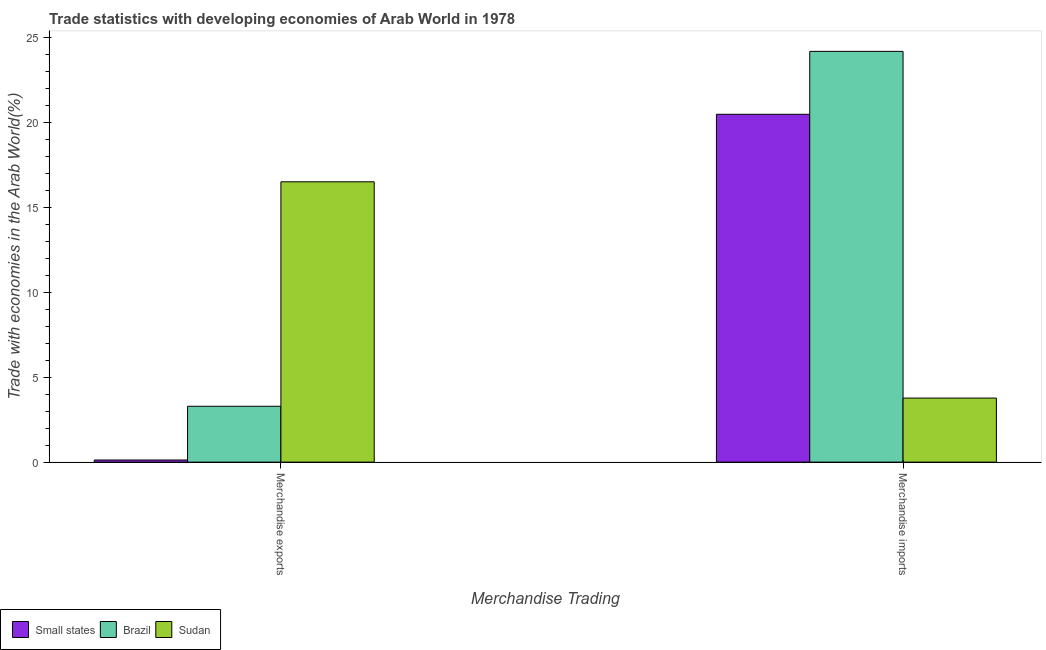How many groups of bars are there?
Make the answer very short. 2. How many bars are there on the 2nd tick from the right?
Provide a succinct answer. 3. What is the label of the 2nd group of bars from the left?
Make the answer very short. Merchandise imports. What is the merchandise exports in Small states?
Offer a terse response. 0.13. Across all countries, what is the maximum merchandise imports?
Offer a very short reply. 24.17. Across all countries, what is the minimum merchandise exports?
Offer a very short reply. 0.13. In which country was the merchandise exports maximum?
Provide a succinct answer. Sudan. In which country was the merchandise imports minimum?
Offer a terse response. Sudan. What is the total merchandise exports in the graph?
Offer a very short reply. 19.91. What is the difference between the merchandise imports in Brazil and that in Sudan?
Your answer should be very brief. 20.4. What is the difference between the merchandise exports in Sudan and the merchandise imports in Brazil?
Keep it short and to the point. -7.67. What is the average merchandise exports per country?
Your answer should be compact. 6.64. What is the difference between the merchandise imports and merchandise exports in Brazil?
Provide a succinct answer. 20.88. What is the ratio of the merchandise exports in Small states to that in Brazil?
Offer a terse response. 0.04. Is the merchandise imports in Sudan less than that in Small states?
Provide a short and direct response. Yes. In how many countries, is the merchandise imports greater than the average merchandise imports taken over all countries?
Your answer should be compact. 2. What does the 3rd bar from the left in Merchandise exports represents?
Provide a short and direct response. Sudan. What does the 1st bar from the right in Merchandise imports represents?
Provide a short and direct response. Sudan. Are all the bars in the graph horizontal?
Ensure brevity in your answer.  No. How many countries are there in the graph?
Offer a very short reply. 3. Are the values on the major ticks of Y-axis written in scientific E-notation?
Your answer should be compact. No. Does the graph contain any zero values?
Offer a terse response. No. Where does the legend appear in the graph?
Offer a very short reply. Bottom left. How many legend labels are there?
Your answer should be very brief. 3. What is the title of the graph?
Make the answer very short. Trade statistics with developing economies of Arab World in 1978. Does "Macao" appear as one of the legend labels in the graph?
Your answer should be compact. No. What is the label or title of the X-axis?
Your answer should be compact. Merchandise Trading. What is the label or title of the Y-axis?
Ensure brevity in your answer.  Trade with economies in the Arab World(%). What is the Trade with economies in the Arab World(%) of Small states in Merchandise exports?
Ensure brevity in your answer.  0.13. What is the Trade with economies in the Arab World(%) in Brazil in Merchandise exports?
Ensure brevity in your answer.  3.29. What is the Trade with economies in the Arab World(%) in Sudan in Merchandise exports?
Your answer should be very brief. 16.49. What is the Trade with economies in the Arab World(%) of Small states in Merchandise imports?
Ensure brevity in your answer.  20.47. What is the Trade with economies in the Arab World(%) in Brazil in Merchandise imports?
Offer a terse response. 24.17. What is the Trade with economies in the Arab World(%) in Sudan in Merchandise imports?
Make the answer very short. 3.77. Across all Merchandise Trading, what is the maximum Trade with economies in the Arab World(%) of Small states?
Offer a terse response. 20.47. Across all Merchandise Trading, what is the maximum Trade with economies in the Arab World(%) of Brazil?
Provide a succinct answer. 24.17. Across all Merchandise Trading, what is the maximum Trade with economies in the Arab World(%) in Sudan?
Keep it short and to the point. 16.49. Across all Merchandise Trading, what is the minimum Trade with economies in the Arab World(%) in Small states?
Keep it short and to the point. 0.13. Across all Merchandise Trading, what is the minimum Trade with economies in the Arab World(%) of Brazil?
Make the answer very short. 3.29. Across all Merchandise Trading, what is the minimum Trade with economies in the Arab World(%) of Sudan?
Keep it short and to the point. 3.77. What is the total Trade with economies in the Arab World(%) of Small states in the graph?
Give a very brief answer. 20.59. What is the total Trade with economies in the Arab World(%) in Brazil in the graph?
Provide a short and direct response. 27.45. What is the total Trade with economies in the Arab World(%) in Sudan in the graph?
Ensure brevity in your answer.  20.26. What is the difference between the Trade with economies in the Arab World(%) in Small states in Merchandise exports and that in Merchandise imports?
Your response must be concise. -20.34. What is the difference between the Trade with economies in the Arab World(%) of Brazil in Merchandise exports and that in Merchandise imports?
Offer a terse response. -20.88. What is the difference between the Trade with economies in the Arab World(%) of Sudan in Merchandise exports and that in Merchandise imports?
Keep it short and to the point. 12.73. What is the difference between the Trade with economies in the Arab World(%) in Small states in Merchandise exports and the Trade with economies in the Arab World(%) in Brazil in Merchandise imports?
Your answer should be compact. -24.04. What is the difference between the Trade with economies in the Arab World(%) of Small states in Merchandise exports and the Trade with economies in the Arab World(%) of Sudan in Merchandise imports?
Provide a succinct answer. -3.64. What is the difference between the Trade with economies in the Arab World(%) in Brazil in Merchandise exports and the Trade with economies in the Arab World(%) in Sudan in Merchandise imports?
Offer a very short reply. -0.48. What is the average Trade with economies in the Arab World(%) in Small states per Merchandise Trading?
Your response must be concise. 10.3. What is the average Trade with economies in the Arab World(%) in Brazil per Merchandise Trading?
Offer a very short reply. 13.73. What is the average Trade with economies in the Arab World(%) of Sudan per Merchandise Trading?
Your answer should be very brief. 10.13. What is the difference between the Trade with economies in the Arab World(%) of Small states and Trade with economies in the Arab World(%) of Brazil in Merchandise exports?
Your answer should be very brief. -3.16. What is the difference between the Trade with economies in the Arab World(%) in Small states and Trade with economies in the Arab World(%) in Sudan in Merchandise exports?
Offer a terse response. -16.37. What is the difference between the Trade with economies in the Arab World(%) of Brazil and Trade with economies in the Arab World(%) of Sudan in Merchandise exports?
Ensure brevity in your answer.  -13.21. What is the difference between the Trade with economies in the Arab World(%) of Small states and Trade with economies in the Arab World(%) of Brazil in Merchandise imports?
Your answer should be very brief. -3.7. What is the difference between the Trade with economies in the Arab World(%) of Small states and Trade with economies in the Arab World(%) of Sudan in Merchandise imports?
Make the answer very short. 16.7. What is the difference between the Trade with economies in the Arab World(%) of Brazil and Trade with economies in the Arab World(%) of Sudan in Merchandise imports?
Ensure brevity in your answer.  20.4. What is the ratio of the Trade with economies in the Arab World(%) of Small states in Merchandise exports to that in Merchandise imports?
Your answer should be very brief. 0.01. What is the ratio of the Trade with economies in the Arab World(%) of Brazil in Merchandise exports to that in Merchandise imports?
Provide a short and direct response. 0.14. What is the ratio of the Trade with economies in the Arab World(%) of Sudan in Merchandise exports to that in Merchandise imports?
Offer a very short reply. 4.38. What is the difference between the highest and the second highest Trade with economies in the Arab World(%) of Small states?
Provide a succinct answer. 20.34. What is the difference between the highest and the second highest Trade with economies in the Arab World(%) of Brazil?
Give a very brief answer. 20.88. What is the difference between the highest and the second highest Trade with economies in the Arab World(%) in Sudan?
Offer a very short reply. 12.73. What is the difference between the highest and the lowest Trade with economies in the Arab World(%) of Small states?
Offer a terse response. 20.34. What is the difference between the highest and the lowest Trade with economies in the Arab World(%) in Brazil?
Your answer should be very brief. 20.88. What is the difference between the highest and the lowest Trade with economies in the Arab World(%) in Sudan?
Keep it short and to the point. 12.73. 